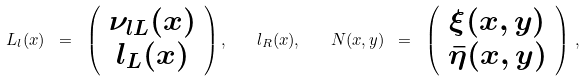Convert formula to latex. <formula><loc_0><loc_0><loc_500><loc_500>L _ { l } ( x ) \ = \ \left ( \begin{array} { c } \nu _ { l L } ( x ) \\ l _ { L } ( x ) \end{array} \right ) , \quad l _ { R } ( x ) , \quad N ( x , y ) \ = \ \left ( \begin{array} { c } \xi ( x , y ) \\ \bar { \eta } ( x , y ) \end{array} \right ) \, ,</formula> 